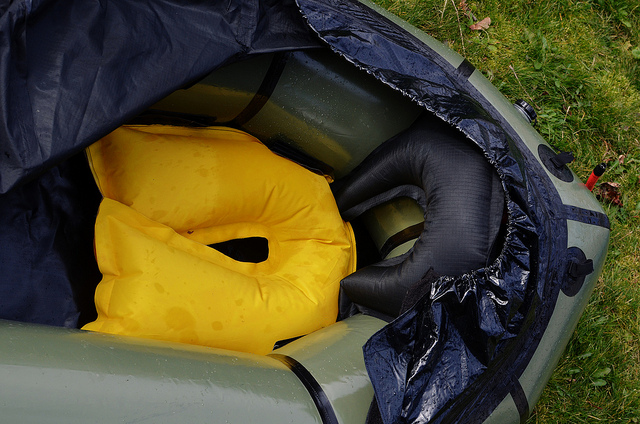<image>Does the life raft float? I'm not sure if the life raft floats. However, based on the consensus of the responses, it seems likely. Does the life raft float? I don't know if the life raft floats. It can be both yes or unknown. 